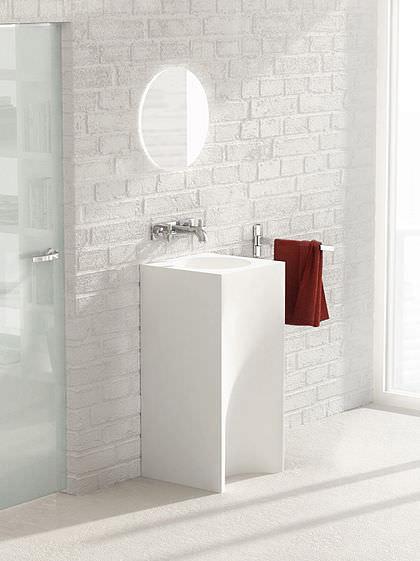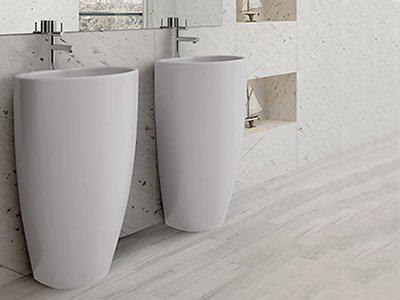The first image is the image on the left, the second image is the image on the right. Given the left and right images, does the statement "The left image shows one white upright sink that stands on the floor, and the right image contains side-by-side but unconnected upright white sinks." hold true? Answer yes or no. Yes. The first image is the image on the left, the second image is the image on the right. Given the left and right images, does the statement "In one image, two tall narrow sinks are standing side by side, while a second image shows a single sink with a towel." hold true? Answer yes or no. Yes. 